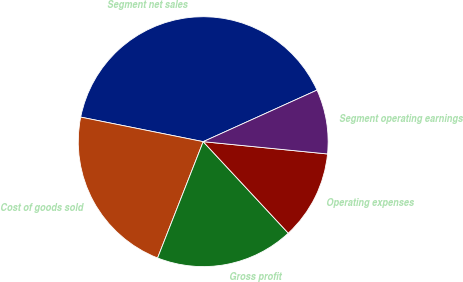Convert chart to OTSL. <chart><loc_0><loc_0><loc_500><loc_500><pie_chart><fcel>Segment net sales<fcel>Cost of goods sold<fcel>Gross profit<fcel>Operating expenses<fcel>Segment operating earnings<nl><fcel>40.08%<fcel>22.2%<fcel>17.87%<fcel>11.51%<fcel>8.34%<nl></chart> 